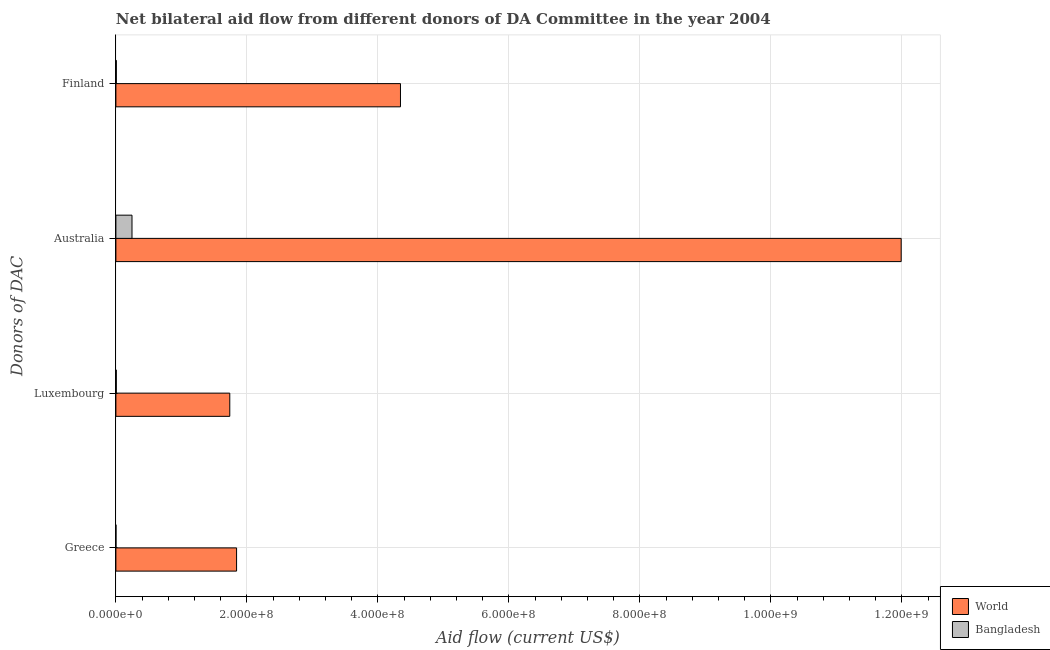How many different coloured bars are there?
Make the answer very short. 2. Are the number of bars per tick equal to the number of legend labels?
Your answer should be very brief. Yes. How many bars are there on the 2nd tick from the top?
Offer a terse response. 2. How many bars are there on the 3rd tick from the bottom?
Give a very brief answer. 2. What is the amount of aid given by finland in World?
Keep it short and to the point. 4.34e+08. Across all countries, what is the maximum amount of aid given by finland?
Keep it short and to the point. 4.34e+08. Across all countries, what is the minimum amount of aid given by greece?
Provide a succinct answer. 1.00e+05. In which country was the amount of aid given by australia maximum?
Give a very brief answer. World. In which country was the amount of aid given by finland minimum?
Ensure brevity in your answer.  Bangladesh. What is the total amount of aid given by finland in the graph?
Offer a terse response. 4.35e+08. What is the difference between the amount of aid given by luxembourg in Bangladesh and that in World?
Give a very brief answer. -1.73e+08. What is the difference between the amount of aid given by australia in World and the amount of aid given by greece in Bangladesh?
Offer a very short reply. 1.20e+09. What is the average amount of aid given by luxembourg per country?
Your response must be concise. 8.72e+07. What is the difference between the amount of aid given by australia and amount of aid given by greece in World?
Provide a succinct answer. 1.01e+09. In how many countries, is the amount of aid given by finland greater than 1200000000 US$?
Offer a terse response. 0. What is the ratio of the amount of aid given by australia in Bangladesh to that in World?
Provide a succinct answer. 0.02. What is the difference between the highest and the second highest amount of aid given by finland?
Your answer should be very brief. 4.34e+08. What is the difference between the highest and the lowest amount of aid given by luxembourg?
Make the answer very short. 1.73e+08. Is it the case that in every country, the sum of the amount of aid given by luxembourg and amount of aid given by greece is greater than the sum of amount of aid given by finland and amount of aid given by australia?
Provide a succinct answer. No. What does the 2nd bar from the bottom in Luxembourg represents?
Give a very brief answer. Bangladesh. Are all the bars in the graph horizontal?
Your answer should be compact. Yes. What is the difference between two consecutive major ticks on the X-axis?
Offer a very short reply. 2.00e+08. Are the values on the major ticks of X-axis written in scientific E-notation?
Make the answer very short. Yes. Does the graph contain any zero values?
Provide a succinct answer. No. Where does the legend appear in the graph?
Provide a short and direct response. Bottom right. How many legend labels are there?
Offer a very short reply. 2. What is the title of the graph?
Keep it short and to the point. Net bilateral aid flow from different donors of DA Committee in the year 2004. Does "Tonga" appear as one of the legend labels in the graph?
Give a very brief answer. No. What is the label or title of the Y-axis?
Your answer should be compact. Donors of DAC. What is the Aid flow (current US$) in World in Greece?
Offer a terse response. 1.84e+08. What is the Aid flow (current US$) of World in Luxembourg?
Keep it short and to the point. 1.74e+08. What is the Aid flow (current US$) of Bangladesh in Luxembourg?
Offer a very short reply. 6.10e+05. What is the Aid flow (current US$) of World in Australia?
Make the answer very short. 1.20e+09. What is the Aid flow (current US$) in Bangladesh in Australia?
Make the answer very short. 2.46e+07. What is the Aid flow (current US$) of World in Finland?
Your answer should be compact. 4.34e+08. What is the Aid flow (current US$) of Bangladesh in Finland?
Give a very brief answer. 6.70e+05. Across all Donors of DAC, what is the maximum Aid flow (current US$) of World?
Your response must be concise. 1.20e+09. Across all Donors of DAC, what is the maximum Aid flow (current US$) of Bangladesh?
Provide a succinct answer. 2.46e+07. Across all Donors of DAC, what is the minimum Aid flow (current US$) in World?
Make the answer very short. 1.74e+08. What is the total Aid flow (current US$) in World in the graph?
Ensure brevity in your answer.  1.99e+09. What is the total Aid flow (current US$) of Bangladesh in the graph?
Offer a terse response. 2.60e+07. What is the difference between the Aid flow (current US$) in World in Greece and that in Luxembourg?
Ensure brevity in your answer.  1.04e+07. What is the difference between the Aid flow (current US$) in Bangladesh in Greece and that in Luxembourg?
Make the answer very short. -5.10e+05. What is the difference between the Aid flow (current US$) of World in Greece and that in Australia?
Ensure brevity in your answer.  -1.01e+09. What is the difference between the Aid flow (current US$) of Bangladesh in Greece and that in Australia?
Provide a succinct answer. -2.45e+07. What is the difference between the Aid flow (current US$) in World in Greece and that in Finland?
Keep it short and to the point. -2.50e+08. What is the difference between the Aid flow (current US$) of Bangladesh in Greece and that in Finland?
Your response must be concise. -5.70e+05. What is the difference between the Aid flow (current US$) in World in Luxembourg and that in Australia?
Make the answer very short. -1.02e+09. What is the difference between the Aid flow (current US$) in Bangladesh in Luxembourg and that in Australia?
Provide a succinct answer. -2.40e+07. What is the difference between the Aid flow (current US$) in World in Luxembourg and that in Finland?
Make the answer very short. -2.61e+08. What is the difference between the Aid flow (current US$) of World in Australia and that in Finland?
Your response must be concise. 7.64e+08. What is the difference between the Aid flow (current US$) of Bangladesh in Australia and that in Finland?
Make the answer very short. 2.39e+07. What is the difference between the Aid flow (current US$) in World in Greece and the Aid flow (current US$) in Bangladesh in Luxembourg?
Ensure brevity in your answer.  1.84e+08. What is the difference between the Aid flow (current US$) of World in Greece and the Aid flow (current US$) of Bangladesh in Australia?
Your answer should be very brief. 1.60e+08. What is the difference between the Aid flow (current US$) in World in Greece and the Aid flow (current US$) in Bangladesh in Finland?
Offer a terse response. 1.84e+08. What is the difference between the Aid flow (current US$) of World in Luxembourg and the Aid flow (current US$) of Bangladesh in Australia?
Offer a very short reply. 1.49e+08. What is the difference between the Aid flow (current US$) in World in Luxembourg and the Aid flow (current US$) in Bangladesh in Finland?
Give a very brief answer. 1.73e+08. What is the difference between the Aid flow (current US$) of World in Australia and the Aid flow (current US$) of Bangladesh in Finland?
Make the answer very short. 1.20e+09. What is the average Aid flow (current US$) of World per Donors of DAC?
Offer a very short reply. 4.98e+08. What is the average Aid flow (current US$) of Bangladesh per Donors of DAC?
Provide a short and direct response. 6.50e+06. What is the difference between the Aid flow (current US$) in World and Aid flow (current US$) in Bangladesh in Greece?
Provide a short and direct response. 1.84e+08. What is the difference between the Aid flow (current US$) of World and Aid flow (current US$) of Bangladesh in Luxembourg?
Offer a very short reply. 1.73e+08. What is the difference between the Aid flow (current US$) of World and Aid flow (current US$) of Bangladesh in Australia?
Provide a succinct answer. 1.17e+09. What is the difference between the Aid flow (current US$) of World and Aid flow (current US$) of Bangladesh in Finland?
Give a very brief answer. 4.34e+08. What is the ratio of the Aid flow (current US$) in World in Greece to that in Luxembourg?
Provide a succinct answer. 1.06. What is the ratio of the Aid flow (current US$) in Bangladesh in Greece to that in Luxembourg?
Keep it short and to the point. 0.16. What is the ratio of the Aid flow (current US$) in World in Greece to that in Australia?
Keep it short and to the point. 0.15. What is the ratio of the Aid flow (current US$) in Bangladesh in Greece to that in Australia?
Your response must be concise. 0. What is the ratio of the Aid flow (current US$) in World in Greece to that in Finland?
Your answer should be very brief. 0.42. What is the ratio of the Aid flow (current US$) of Bangladesh in Greece to that in Finland?
Make the answer very short. 0.15. What is the ratio of the Aid flow (current US$) in World in Luxembourg to that in Australia?
Offer a terse response. 0.14. What is the ratio of the Aid flow (current US$) in Bangladesh in Luxembourg to that in Australia?
Offer a very short reply. 0.02. What is the ratio of the Aid flow (current US$) of World in Luxembourg to that in Finland?
Keep it short and to the point. 0.4. What is the ratio of the Aid flow (current US$) in Bangladesh in Luxembourg to that in Finland?
Ensure brevity in your answer.  0.91. What is the ratio of the Aid flow (current US$) of World in Australia to that in Finland?
Your response must be concise. 2.76. What is the ratio of the Aid flow (current US$) in Bangladesh in Australia to that in Finland?
Provide a short and direct response. 36.72. What is the difference between the highest and the second highest Aid flow (current US$) in World?
Make the answer very short. 7.64e+08. What is the difference between the highest and the second highest Aid flow (current US$) in Bangladesh?
Make the answer very short. 2.39e+07. What is the difference between the highest and the lowest Aid flow (current US$) of World?
Your response must be concise. 1.02e+09. What is the difference between the highest and the lowest Aid flow (current US$) in Bangladesh?
Keep it short and to the point. 2.45e+07. 